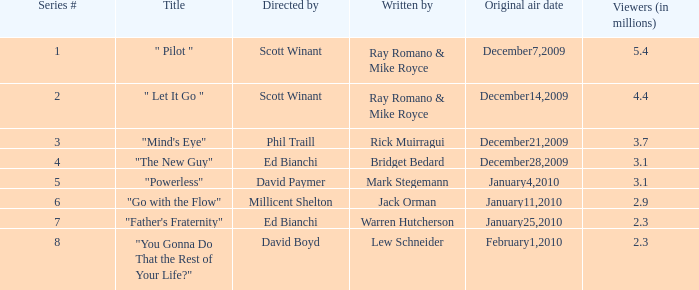What is the original air date of "Powerless"? January4,2010. 